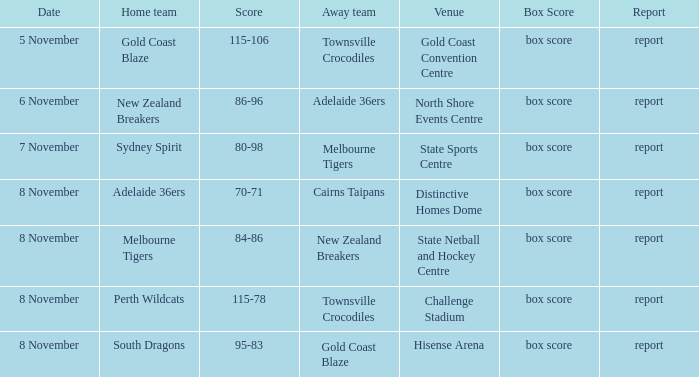What was the box score during a home game of the Adelaide 36ers? Box score. Would you mind parsing the complete table? {'header': ['Date', 'Home team', 'Score', 'Away team', 'Venue', 'Box Score', 'Report'], 'rows': [['5 November', 'Gold Coast Blaze', '115-106', 'Townsville Crocodiles', 'Gold Coast Convention Centre', 'box score', 'report'], ['6 November', 'New Zealand Breakers', '86-96', 'Adelaide 36ers', 'North Shore Events Centre', 'box score', 'report'], ['7 November', 'Sydney Spirit', '80-98', 'Melbourne Tigers', 'State Sports Centre', 'box score', 'report'], ['8 November', 'Adelaide 36ers', '70-71', 'Cairns Taipans', 'Distinctive Homes Dome', 'box score', 'report'], ['8 November', 'Melbourne Tigers', '84-86', 'New Zealand Breakers', 'State Netball and Hockey Centre', 'box score', 'report'], ['8 November', 'Perth Wildcats', '115-78', 'Townsville Crocodiles', 'Challenge Stadium', 'box score', 'report'], ['8 November', 'South Dragons', '95-83', 'Gold Coast Blaze', 'Hisense Arena', 'box score', 'report']]} 